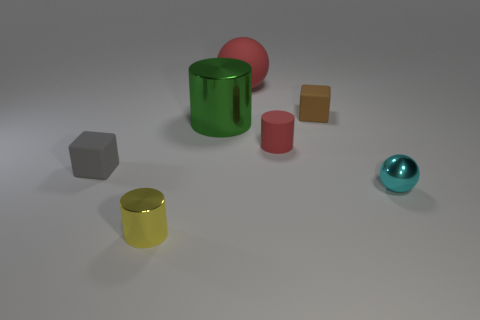How many other things are the same shape as the small cyan metal thing?
Your answer should be very brief. 1. Do the gray thing and the sphere that is in front of the tiny brown matte cube have the same size?
Offer a terse response. Yes. What number of objects are objects right of the tiny matte cylinder or green blocks?
Keep it short and to the point. 2. There is a tiny rubber thing on the left side of the red rubber ball; what shape is it?
Keep it short and to the point. Cube. Are there an equal number of tiny gray things in front of the small gray matte thing and green shiny objects right of the small red rubber cylinder?
Provide a succinct answer. Yes. The matte object that is on the right side of the big matte ball and to the left of the brown rubber block is what color?
Ensure brevity in your answer.  Red. What material is the small cyan object to the right of the small metallic thing that is left of the big red object?
Your response must be concise. Metal. Is the size of the yellow metal cylinder the same as the red matte cylinder?
Provide a succinct answer. Yes. What number of large things are gray objects or rubber blocks?
Provide a short and direct response. 0. What number of balls are on the left side of the small ball?
Offer a terse response. 1. 